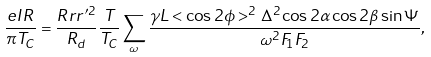Convert formula to latex. <formula><loc_0><loc_0><loc_500><loc_500>\frac { e I R } { \pi T _ { C } } = \frac { R r r ^ { \prime 2 } } { R _ { d } } \frac { T } { T _ { C } } \sum _ { \omega } \frac { \gamma L < \cos 2 \phi > ^ { 2 } \Delta ^ { 2 } \cos 2 \alpha \cos 2 \beta \sin \Psi } { \omega ^ { 2 } F _ { 1 } F _ { 2 } } ,</formula> 